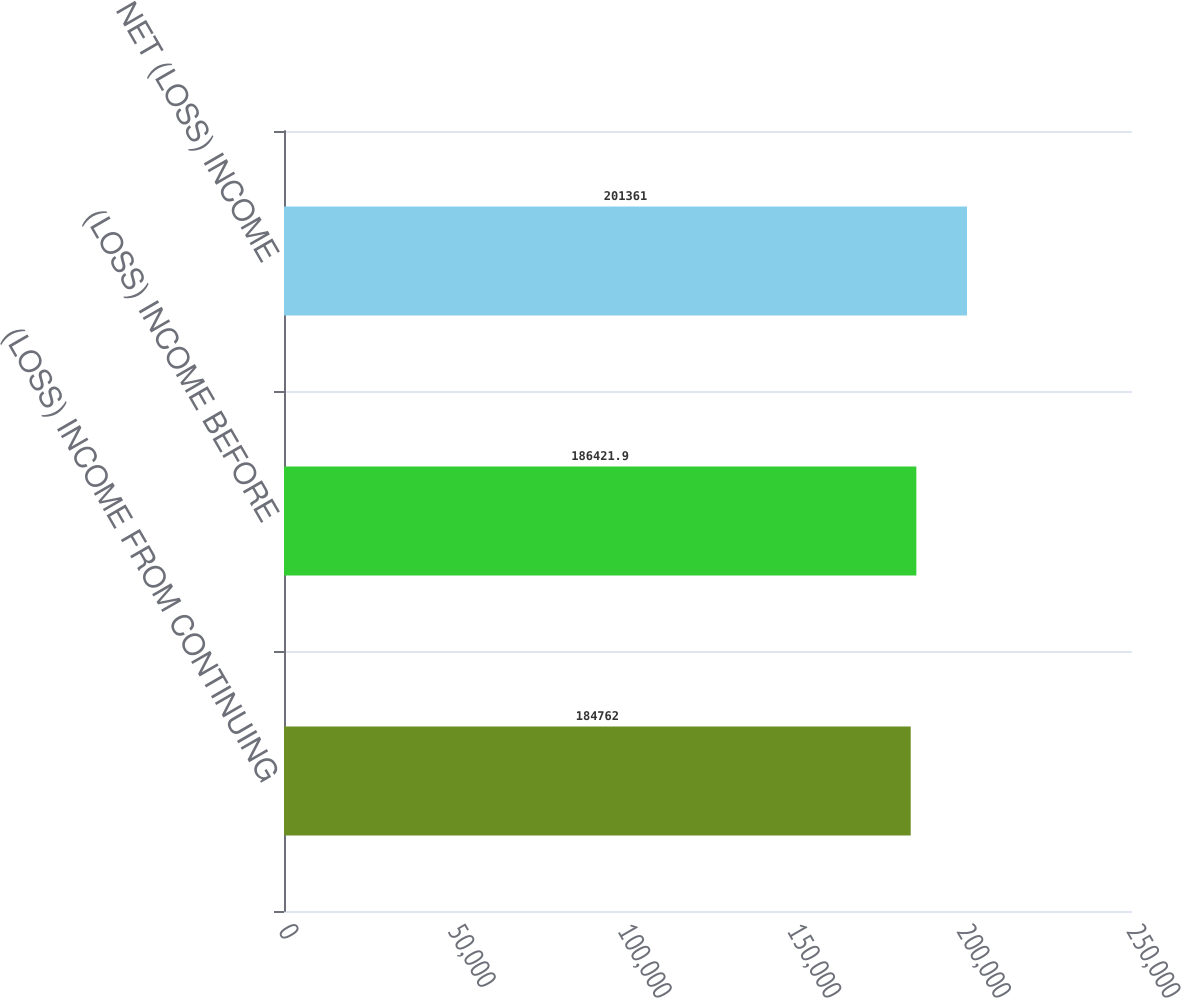<chart> <loc_0><loc_0><loc_500><loc_500><bar_chart><fcel>(LOSS) INCOME FROM CONTINUING<fcel>(LOSS) INCOME BEFORE<fcel>NET (LOSS) INCOME<nl><fcel>184762<fcel>186422<fcel>201361<nl></chart> 